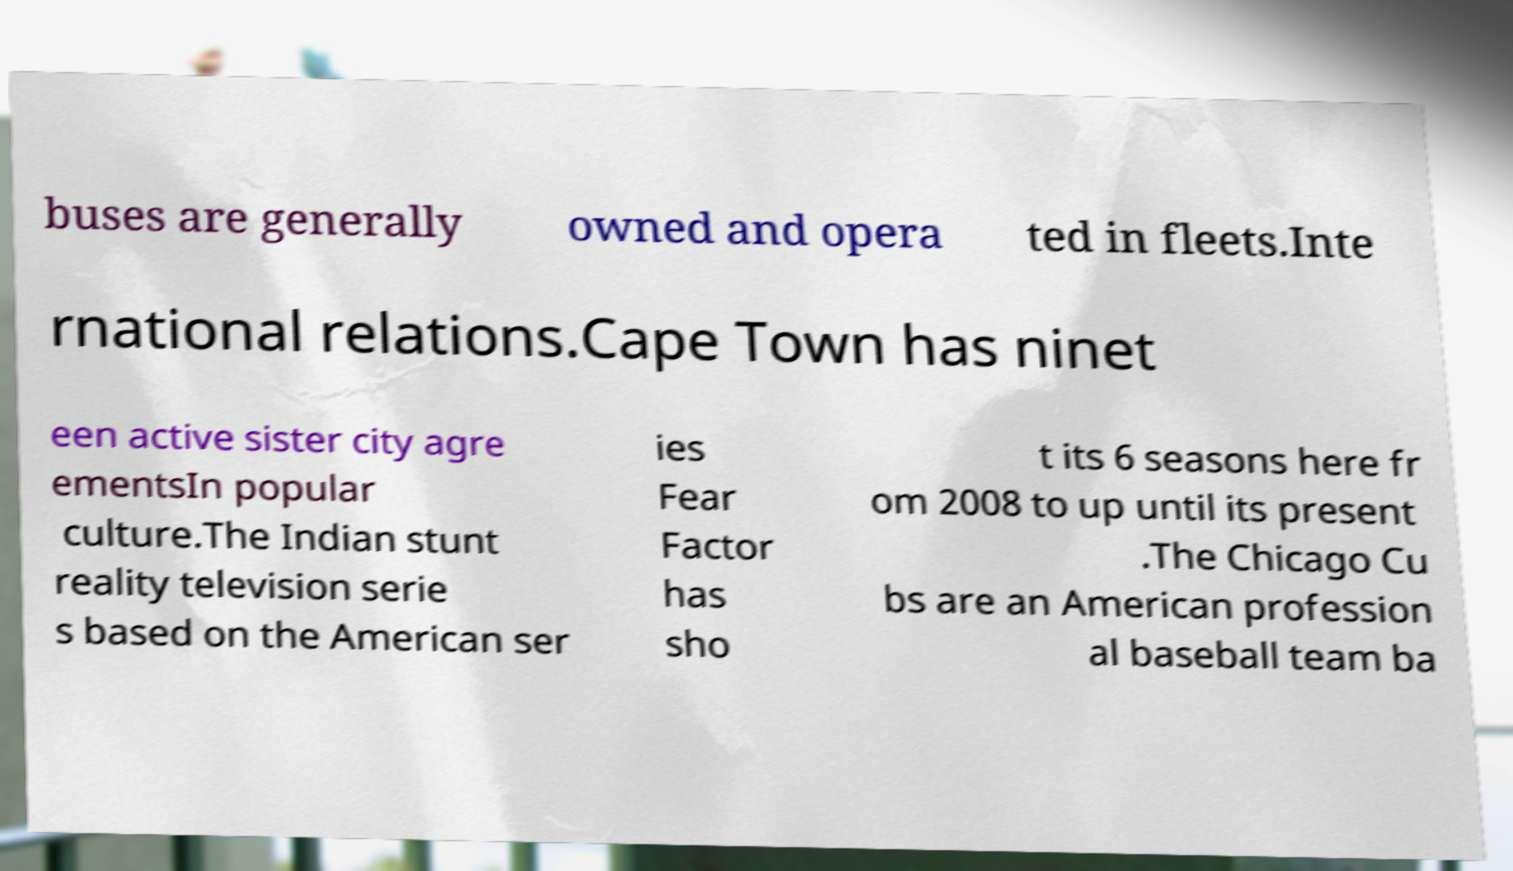Could you assist in decoding the text presented in this image and type it out clearly? buses are generally owned and opera ted in fleets.Inte rnational relations.Cape Town has ninet een active sister city agre ementsIn popular culture.The Indian stunt reality television serie s based on the American ser ies Fear Factor has sho t its 6 seasons here fr om 2008 to up until its present .The Chicago Cu bs are an American profession al baseball team ba 